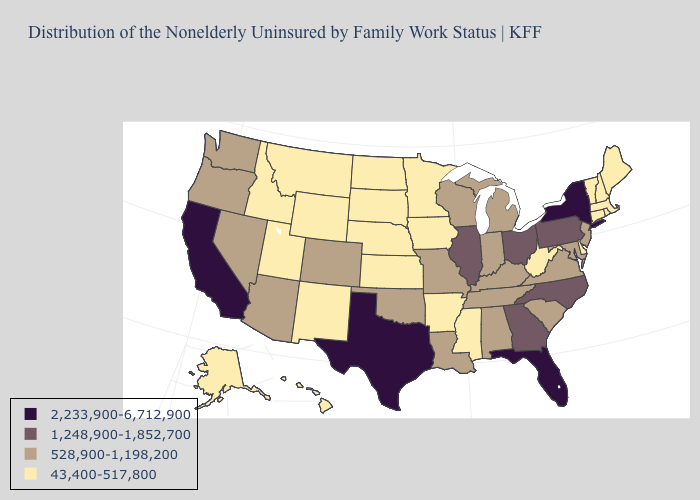Does Oregon have the lowest value in the West?
Give a very brief answer. No. Which states have the lowest value in the USA?
Keep it brief. Alaska, Arkansas, Connecticut, Delaware, Hawaii, Idaho, Iowa, Kansas, Maine, Massachusetts, Minnesota, Mississippi, Montana, Nebraska, New Hampshire, New Mexico, North Dakota, Rhode Island, South Dakota, Utah, Vermont, West Virginia, Wyoming. Name the states that have a value in the range 1,248,900-1,852,700?
Be succinct. Georgia, Illinois, North Carolina, Ohio, Pennsylvania. Does the first symbol in the legend represent the smallest category?
Be succinct. No. Does Texas have the highest value in the USA?
Answer briefly. Yes. Name the states that have a value in the range 528,900-1,198,200?
Be succinct. Alabama, Arizona, Colorado, Indiana, Kentucky, Louisiana, Maryland, Michigan, Missouri, Nevada, New Jersey, Oklahoma, Oregon, South Carolina, Tennessee, Virginia, Washington, Wisconsin. Does California have the highest value in the West?
Short answer required. Yes. Among the states that border Michigan , does Indiana have the highest value?
Be succinct. No. What is the highest value in the USA?
Concise answer only. 2,233,900-6,712,900. Among the states that border South Carolina , which have the highest value?
Write a very short answer. Georgia, North Carolina. Among the states that border Nebraska , does Missouri have the highest value?
Short answer required. Yes. What is the value of Illinois?
Concise answer only. 1,248,900-1,852,700. Does the map have missing data?
Give a very brief answer. No. Which states have the highest value in the USA?
Short answer required. California, Florida, New York, Texas. Which states have the lowest value in the USA?
Short answer required. Alaska, Arkansas, Connecticut, Delaware, Hawaii, Idaho, Iowa, Kansas, Maine, Massachusetts, Minnesota, Mississippi, Montana, Nebraska, New Hampshire, New Mexico, North Dakota, Rhode Island, South Dakota, Utah, Vermont, West Virginia, Wyoming. 